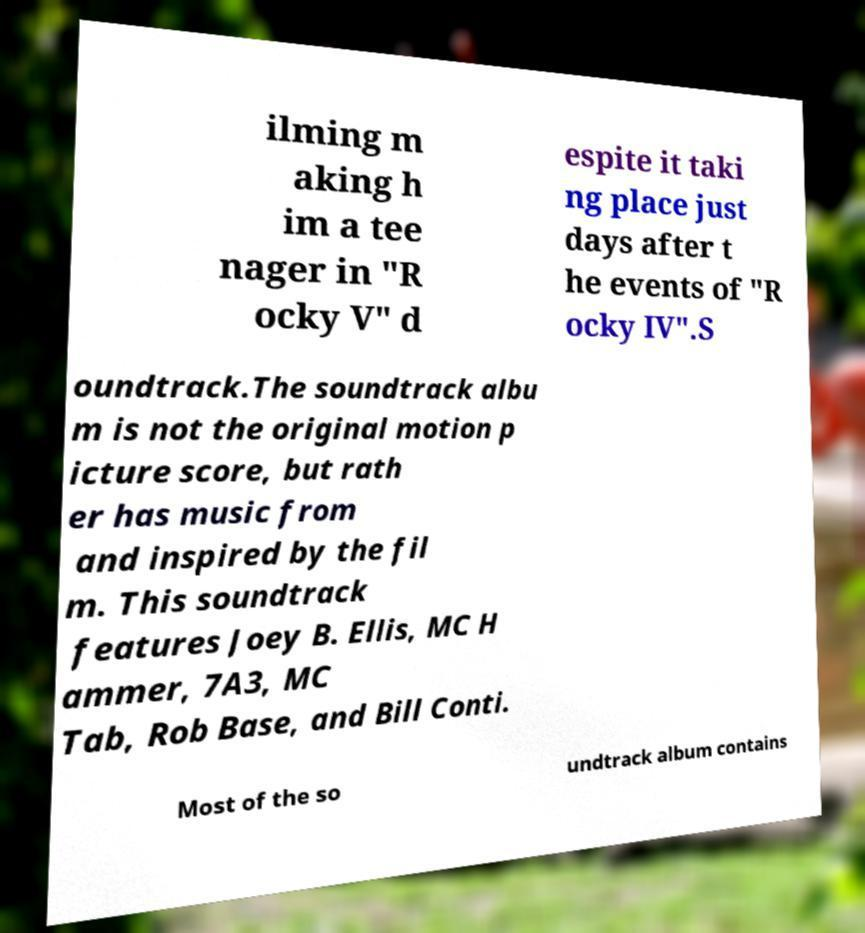Could you assist in decoding the text presented in this image and type it out clearly? ilming m aking h im a tee nager in "R ocky V" d espite it taki ng place just days after t he events of "R ocky IV".S oundtrack.The soundtrack albu m is not the original motion p icture score, but rath er has music from and inspired by the fil m. This soundtrack features Joey B. Ellis, MC H ammer, 7A3, MC Tab, Rob Base, and Bill Conti. Most of the so undtrack album contains 